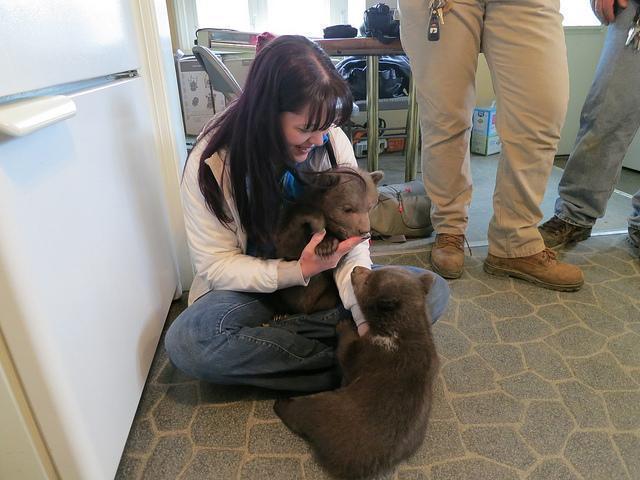What is she sitting next to on the left?
Pick the correct solution from the four options below to address the question.
Options: Microwave, stove, dishwasher, fridge. Fridge. 